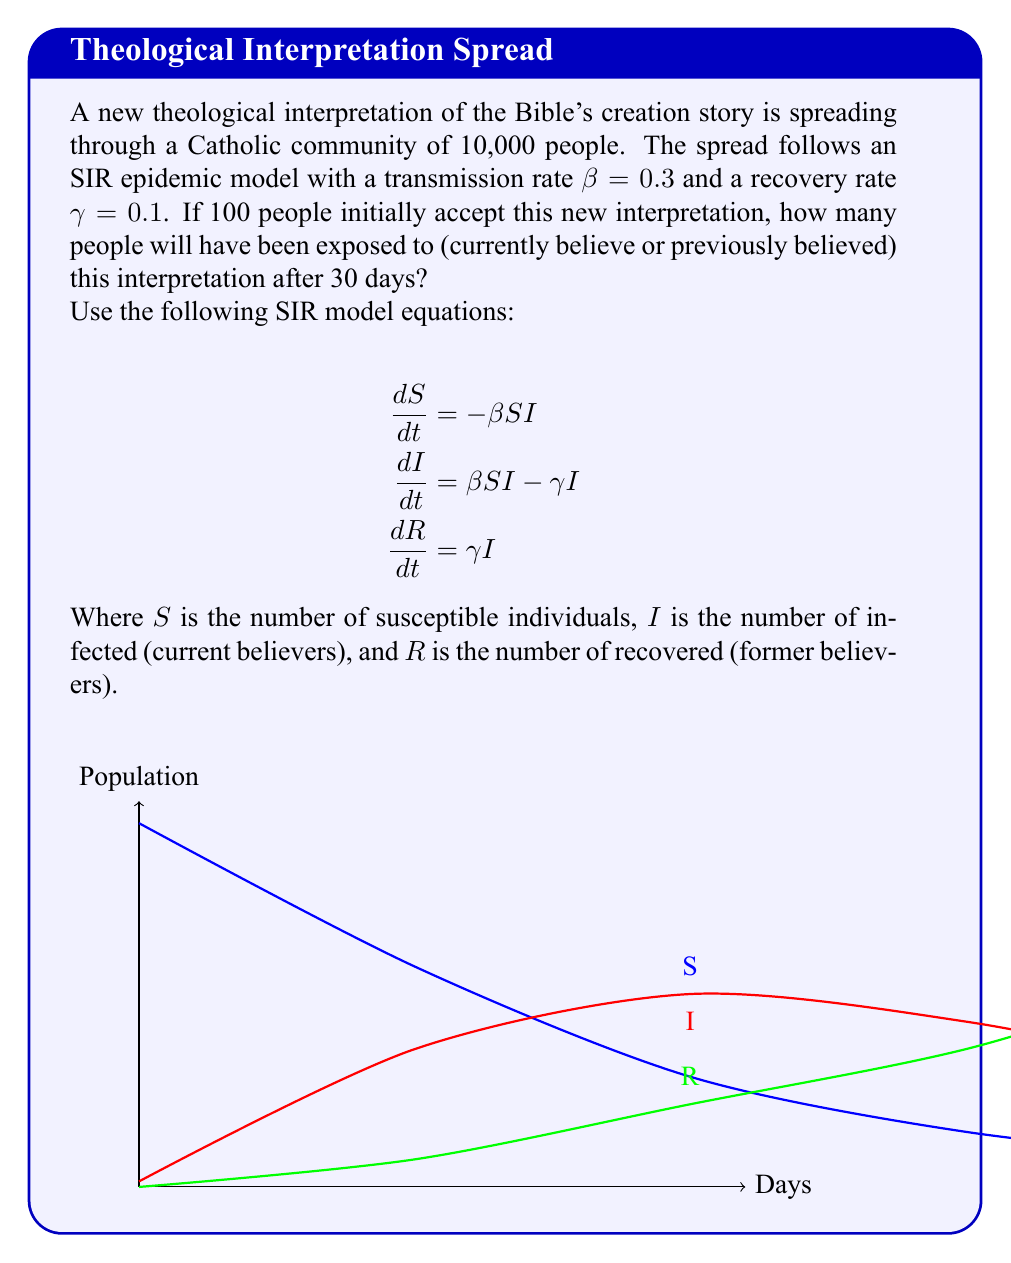Show me your answer to this math problem. To solve this problem, we need to use numerical methods to approximate the solution of the SIR model equations. We'll use the Euler method with a time step of 1 day.

Given:
- Total population: $N = 10,000$
- Initial infected: $I_0 = 100$
- Initial susceptible: $S_0 = N - I_0 = 9,900$
- Initial recovered: $R_0 = 0$
- $\beta = 0.3$
- $\gamma = 0.1$
- Time: $t = 30$ days

Step 1: Set up the iteration equations:
$$S_{t+1} = S_t - \beta S_t I_t / N$$
$$I_{t+1} = I_t + \beta S_t I_t / N - \gamma I_t$$
$$R_{t+1} = R_t + \gamma I_t$$

Step 2: Iterate for 30 days:

Day 0: $S_0 = 9900$, $I_0 = 100$, $R_0 = 0$

Day 1:
$S_1 = 9900 - 0.3 * 9900 * 100 / 10000 = 9603$
$I_1 = 100 + 0.3 * 9900 * 100 / 10000 - 0.1 * 100 = 387$
$R_1 = 0 + 0.1 * 100 = 10$

We continue this process for 30 days. After the 30th iteration:

$S_{30} \approx 1466$
$I_{30} \approx 4534$
$R_{30} \approx 4000$

Step 3: Calculate the total number of people exposed:
Total exposed = Initial population - Final susceptible
$= N - S_{30} = 10000 - 1466 = 8534$
Answer: 8534 people 